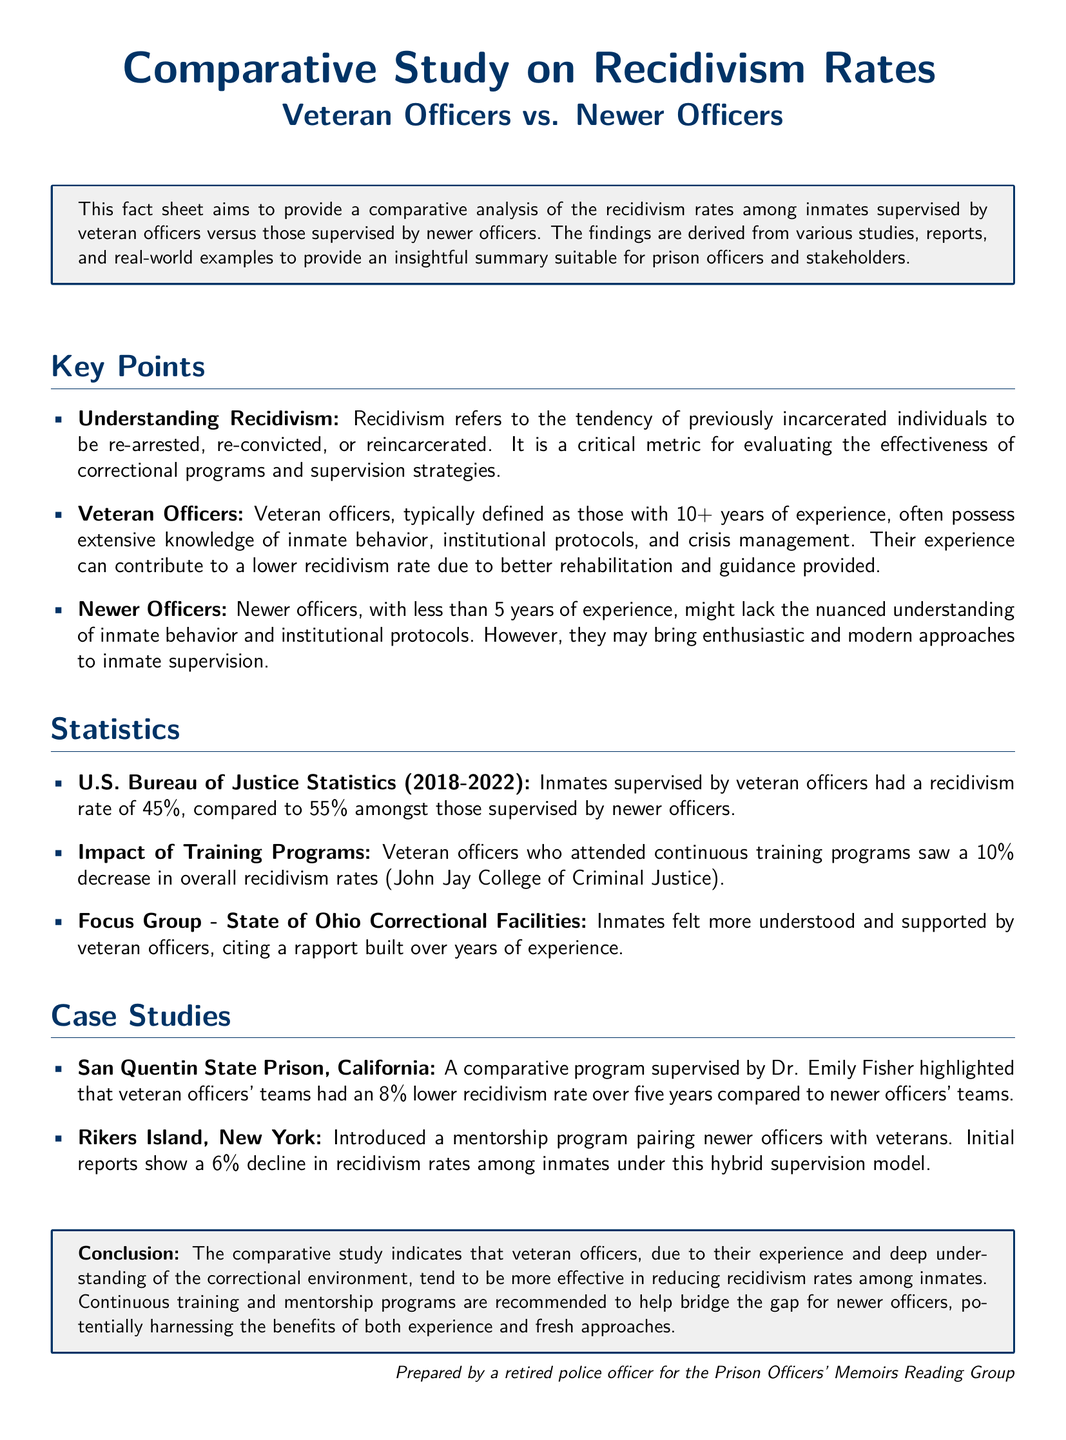what is recidivism? Recidivism refers to the tendency of previously incarcerated individuals to be re-arrested, re-convicted, or reincarcerated.
Answer: tendency of previously incarcerated individuals to be re-arrested, re-convicted, or reincarcerated how many years of experience defines veteran officers? Veteran officers are typically defined as those with 10 or more years of experience.
Answer: 10+ years what is the recidivism rate for inmates supervised by veteran officers? Inmates supervised by veteran officers had a recidivism rate of 45%.
Answer: 45% what training effect did veteran officers attend? Veteran officers who attended continuous training programs saw a decrease in overall recidivism rates.
Answer: 10% decrease which facility reported an 8% lower recidivism rate for veteran officers? At San Quentin State Prison, veteran officers’ teams had an 8% lower recidivism rate.
Answer: San Quentin State Prison what is indicated by the conclusion about veteran officers? The conclusion indicates that veteran officers tend to be more effective in reducing recidivism rates among inmates.
Answer: more effective what program was introduced at Rikers Island? Rikers Island introduced a mentorship program pairing newer officers with veterans.
Answer: mentorship program who prepared the document? The document was prepared by a retired police officer.
Answer: a retired police officer 